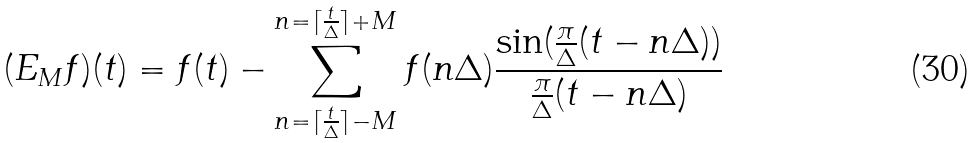Convert formula to latex. <formula><loc_0><loc_0><loc_500><loc_500>( E _ { M } f ) ( t ) = f ( t ) - \sum _ { n = \lceil \frac { t } { \Delta } \rceil - M } ^ { n = \lceil \frac { t } { \Delta } \rceil + M } f ( n \Delta ) \frac { \sin ( \frac { \pi } { \Delta } ( t - n \Delta ) ) } { \frac { \pi } { \Delta } ( t - n \Delta ) }</formula> 